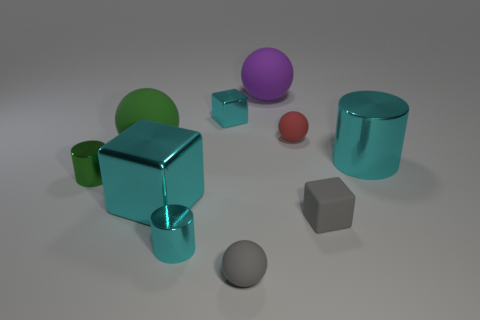What number of small gray objects are on the left side of the tiny matte thing that is right of the red thing?
Make the answer very short. 1. Are the sphere that is in front of the tiny gray matte block and the cyan object in front of the tiny gray cube made of the same material?
Your answer should be compact. No. What is the material of the large object that is the same color as the large cylinder?
Your answer should be very brief. Metal. How many small gray rubber things have the same shape as the purple rubber thing?
Offer a very short reply. 1. Are the large purple ball and the tiny ball on the left side of the big purple ball made of the same material?
Offer a terse response. Yes. There is a cyan cylinder that is the same size as the red ball; what material is it?
Keep it short and to the point. Metal. Is there a block that has the same size as the purple sphere?
Offer a very short reply. Yes. The matte thing that is the same size as the purple matte ball is what shape?
Provide a short and direct response. Sphere. What number of other objects are the same color as the large block?
Provide a short and direct response. 3. What shape is the object that is in front of the purple rubber thing and behind the tiny red ball?
Provide a succinct answer. Cube. 